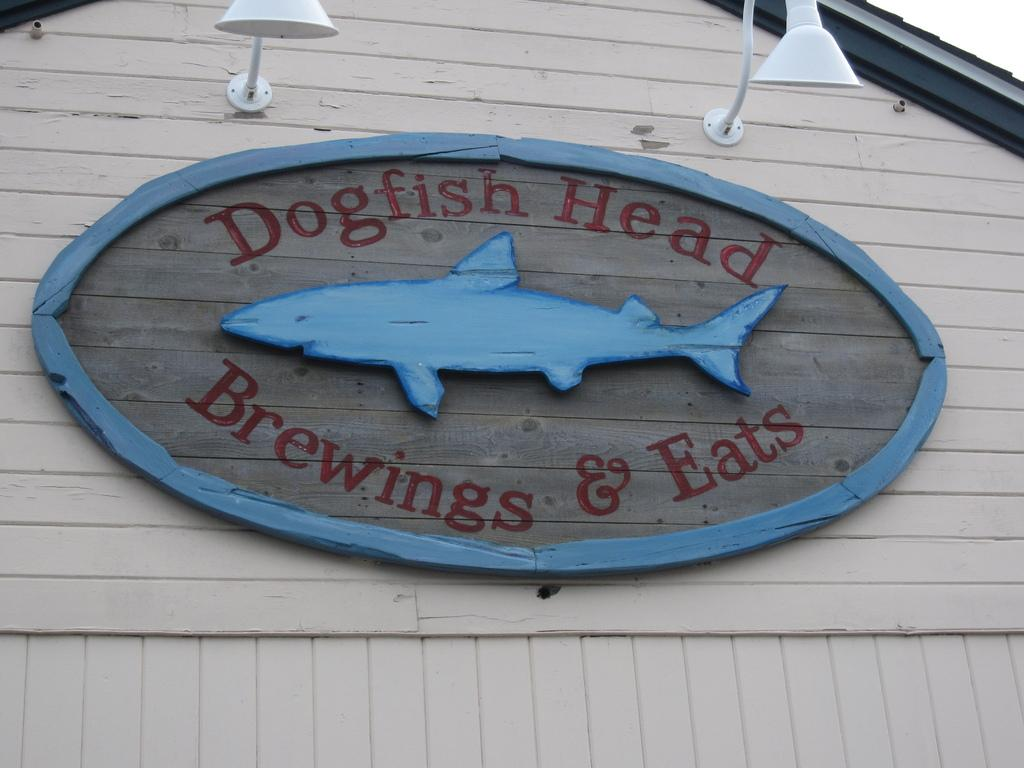What is the main object in the image? There is a board in the image. What is depicted on the board? There is a picture of a fish on the board. What else is present on the board besides the fish image? There is text on the board. What can be seen in the background of the image? There are lights visible in the image, and there is a wooden wall in the background. How would you describe the sky in the image? The sky is white in the image. What time of day is it in the image, given the presence of the moon? There is no moon present in the image, so it is not possible to determine the time of day based on that information. 